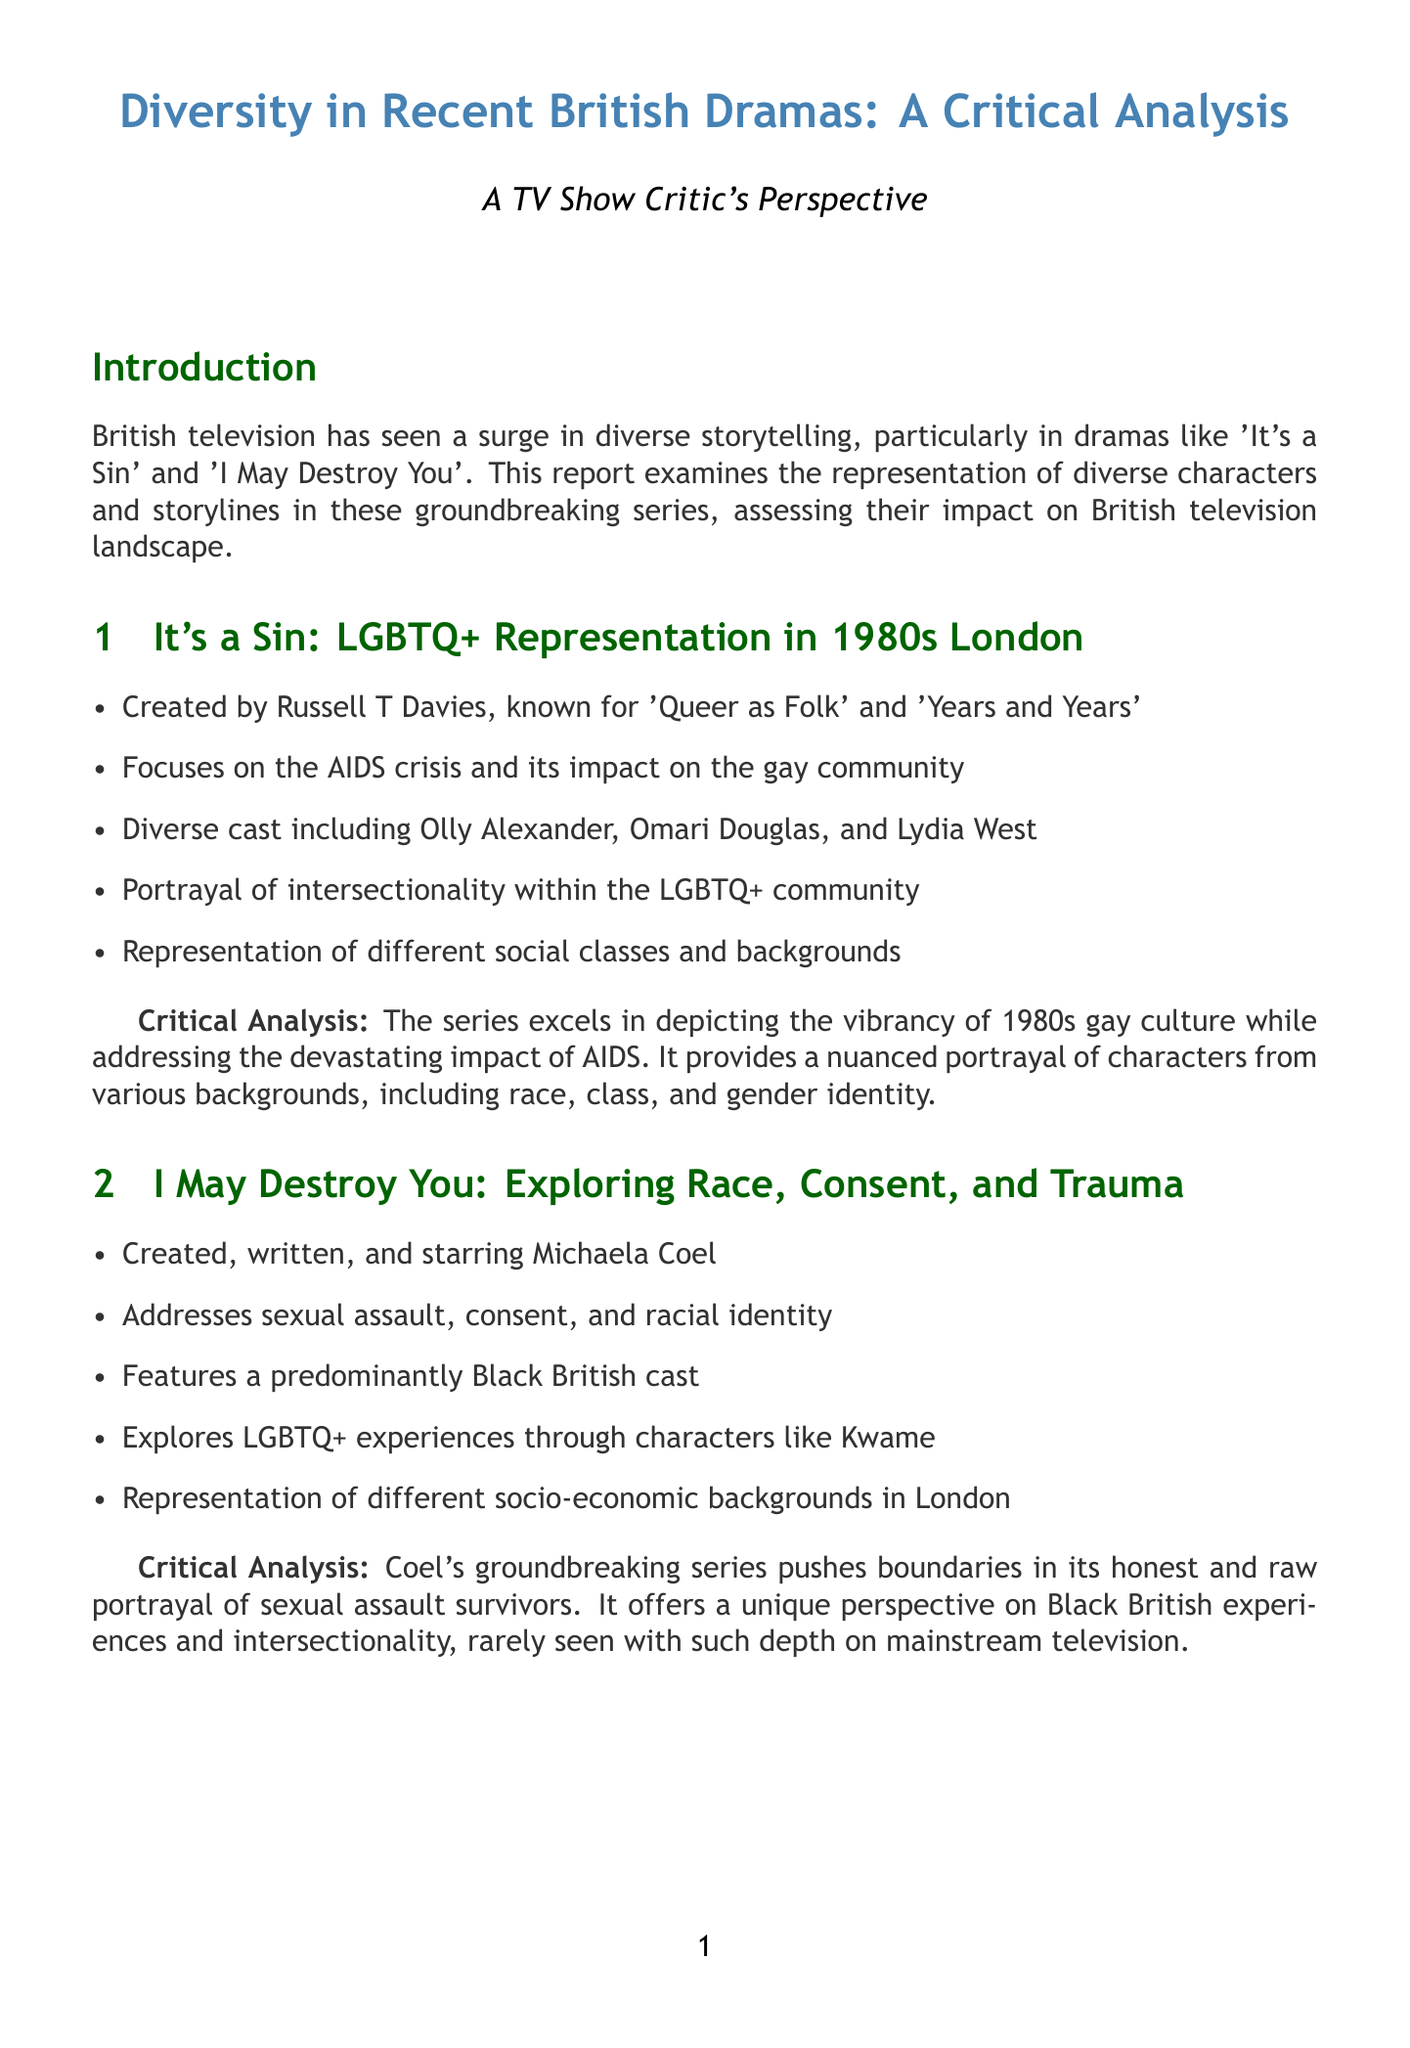What is the title of the report? The title of the report is explicitly stated at the beginning, summarizing its content.
Answer: Diversity in Recent British Dramas: A Critical Analysis Who created 'It's a Sin'? The document identifies Russell T Davies as the creator of the series, highlighting his previous works.
Answer: Russell T Davies What major issue does 'It's a Sin' focus on? The report mentions the AIDS crisis and its impact on the gay community as a primary theme of the series.
Answer: AIDS crisis Which character in 'I May Destroy You' explores LGBTQ+ experiences? The document specifically names a character that represents LGBTQ+ themes in the series.
Answer: Kwame What recognition did both series receive? The report notes that both series have been recognized at major awards shows, underscoring their impact on the industry.
Answer: BAFTAs, Emmys How does 'I May Destroy You' approach the themes of race and consent? The document comments on the series' engagement with critical societal issues, combining race and personal experiences.
Answer: Addresses sexual assault, consent, and racial identity What was a significant impact of the series on the television industry? The document highlights the change in demand for diverse stories as a consequence of these series.
Answer: Increased demand for diverse stories and creators What does the conclusion suggest about future productions? The conclusion mentions that these series set a new standard for representation, impacting future storytelling.
Answer: Influencing future productions and opening doors for more diverse voices 